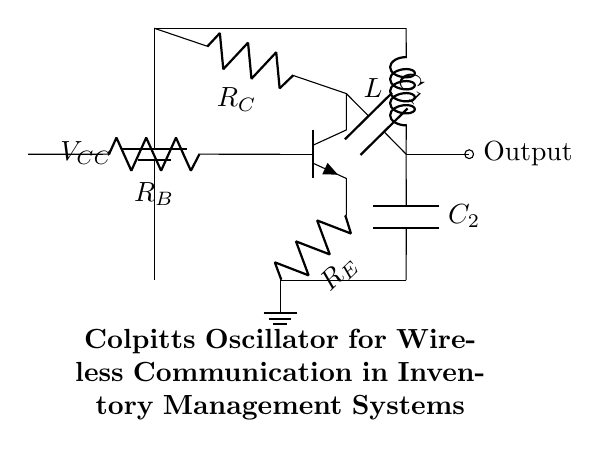What type of transistor is used in the oscillator? The diagram shows an NP transistor, which can be identified by the symbol in the circuit. The three terminals are shown, confirming it is an NP transistor.
Answer: NP transistor What are the names of the capacitors in the circuit? The circuit includes two capacitors labeled as C1 and C2, which are shown in the visual representation connected to the transistor and ground.
Answer: C1, C2 How many resistors are present in the circuit? The circuit contains three resistors, as indicated by their symbols and labels: RC, RE, and RB. Each is connected to different parts of the circuit.
Answer: 3 Which component provides the output signal? The output is taken from the node connected to the transistor and is shown as an output circle labeled in the diagram, indicating where the output signal is extracted.
Answer: Transistor What is the supply voltage in the circuit? The circuit mentions a voltage supply labeled as VCC; typically, this represents the main power supply to the circuit. The exact value is not specified but is commonly a positive voltage.
Answer: VCC How does the oscillator generate oscillation? The combination of capacitors C1 and C2 along with the inductor L forms a tank circuit that produces oscillation through energy storage and discharge. This creates the resonant frequency necessary for oscillation.
Answer: Tank circuit What role does R_E play in the circuit? R_E serves as the emitter resistor, which provides stability and sets the emitter current of the transistor, affecting the oscillation amplitude and stability.
Answer: Emitter resistor 